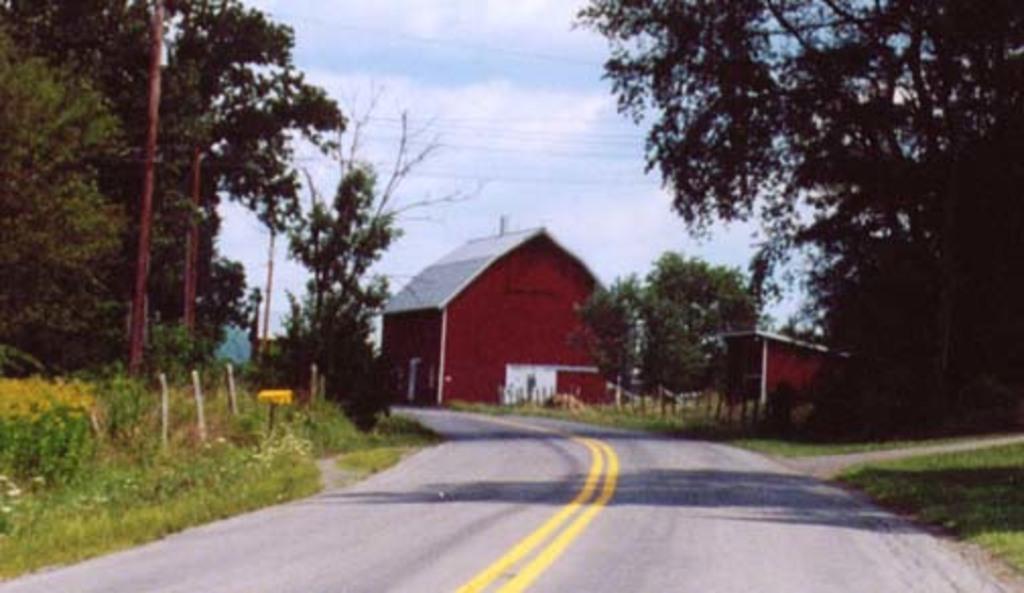In one or two sentences, can you explain what this image depicts? In the picture we can see a road in the middle of the road we can see two yellow lines and on the either sides of the road we can see grass surfaces, plants, trees, and poles and on the opposite side, we can also see some houses which are brown in color and in the background we can see a sky with clouds. 